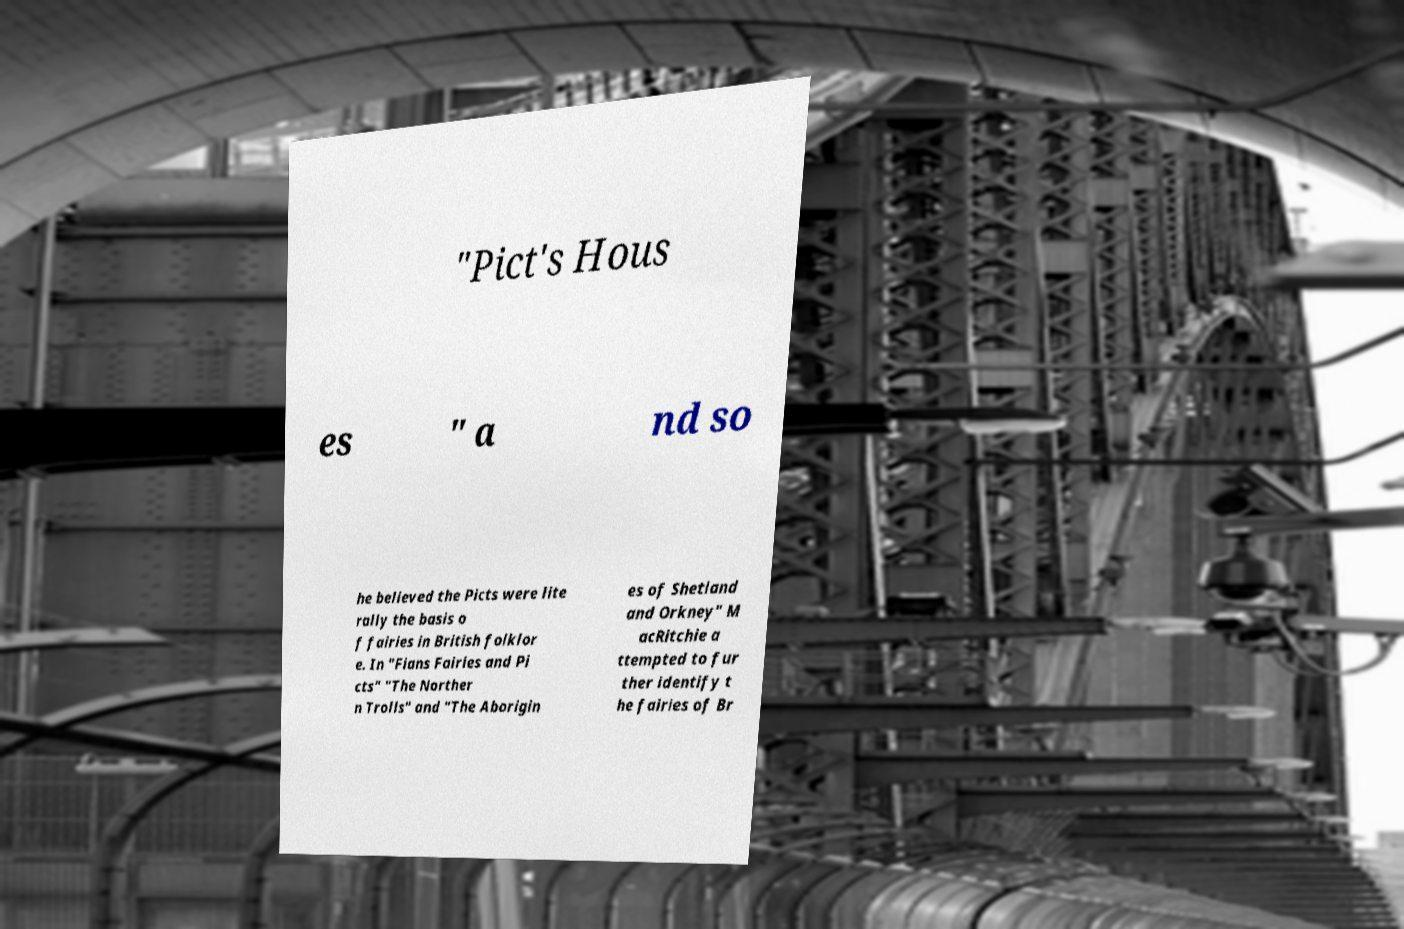Can you read and provide the text displayed in the image?This photo seems to have some interesting text. Can you extract and type it out for me? "Pict's Hous es " a nd so he believed the Picts were lite rally the basis o f fairies in British folklor e. In "Fians Fairies and Pi cts" "The Norther n Trolls" and "The Aborigin es of Shetland and Orkney" M acRitchie a ttempted to fur ther identify t he fairies of Br 